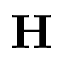<formula> <loc_0><loc_0><loc_500><loc_500>H</formula> 